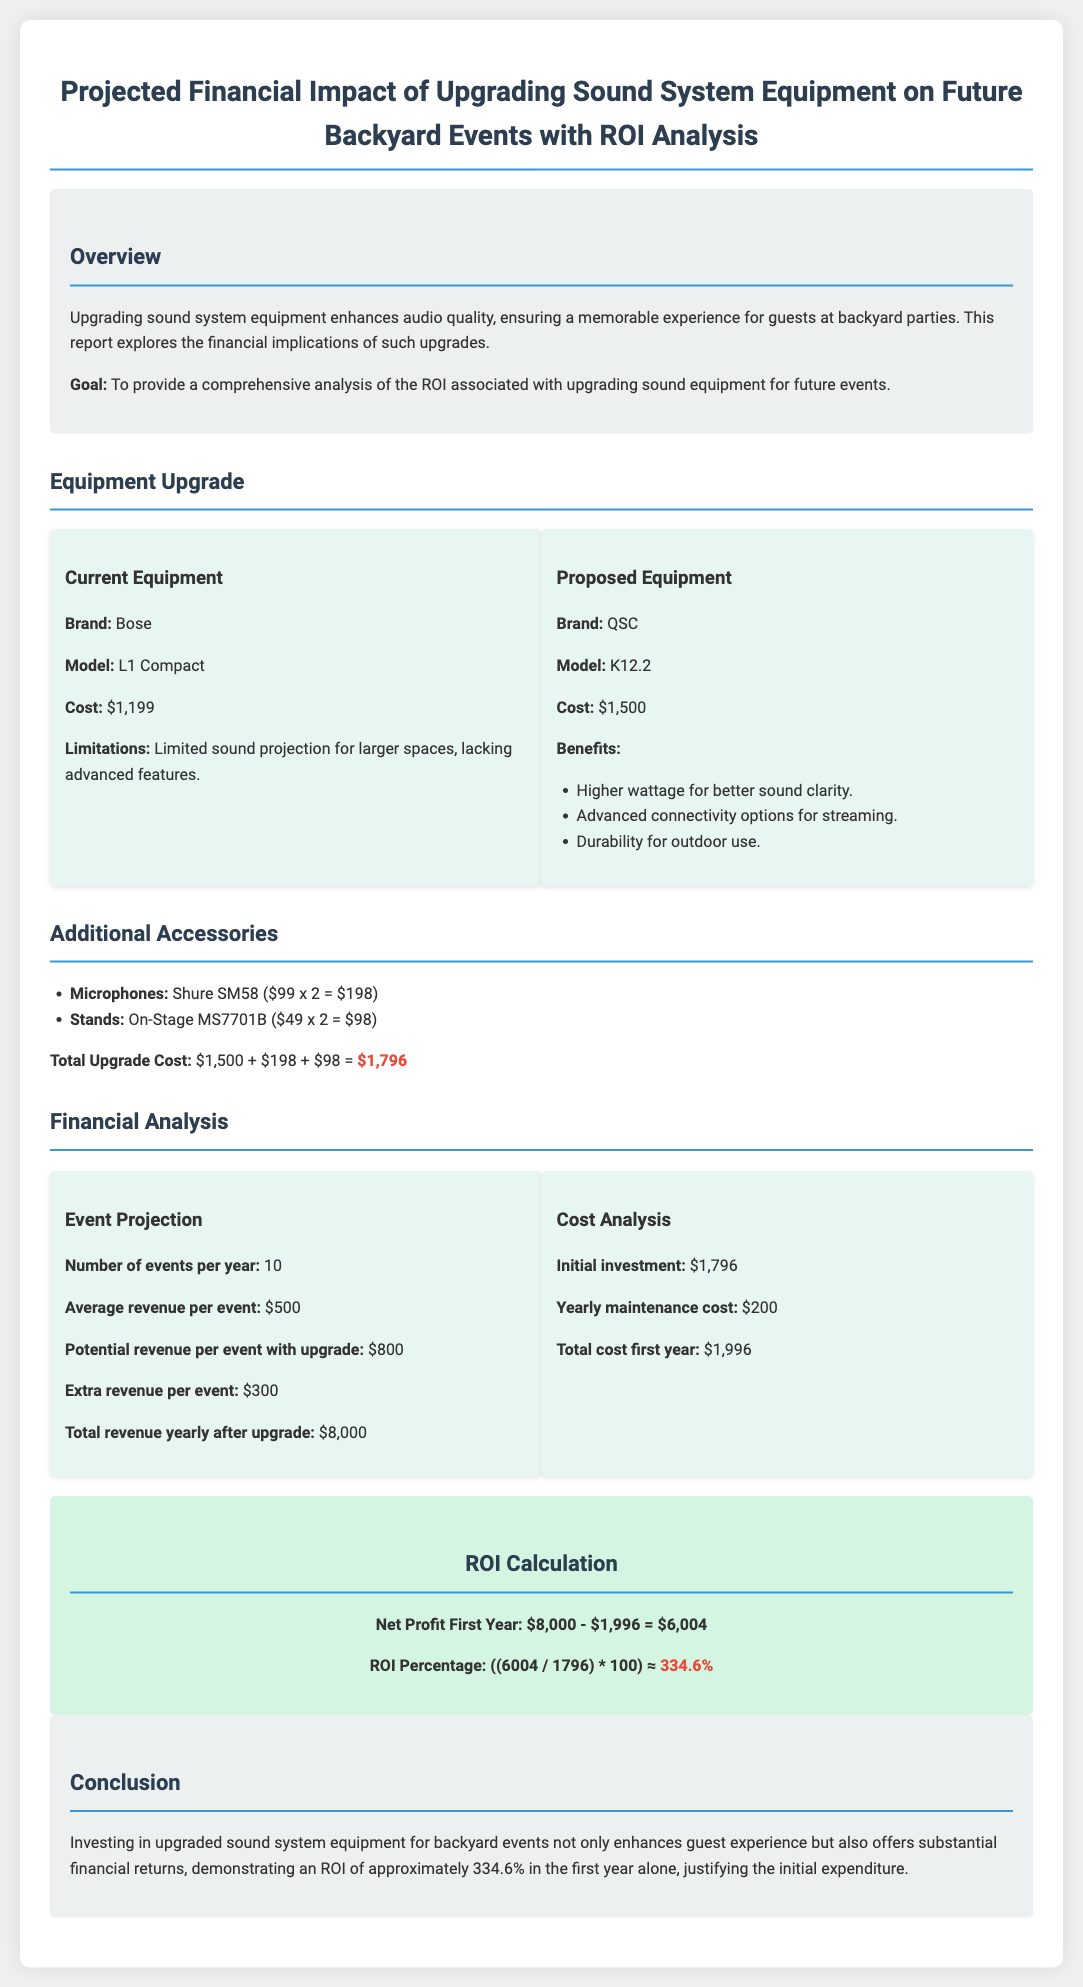What is the current sound system brand? The document states that the current sound system brand is Bose.
Answer: Bose What is the cost of the proposed equipment? The proposed equipment, QSC K12.2, costs $1,500 according to the document.
Answer: $1,500 What is the total upgrade cost for the sound system? The total upgrade cost is calculated as $1,500 + $198 + $98, which equals $1,796.
Answer: $1,796 How many events are projected per year? The document indicates that the number of events projected per year is 10.
Answer: 10 What is the ROI percentage calculated in the report? The report states that the ROI percentage is approximately 334.6%.
Answer: 334.6% What is the initial investment mentioned in the cost analysis? The initial investment highlighted in the cost analysis is $1,796.
Answer: $1,796 What is the extra revenue per event after the upgrade? The document states that the extra revenue per event with the upgrade is $300.
Answer: $300 What is the total revenue yearly after the upgrade? The total revenue yearly after the upgrade is mentioned as $8,000.
Answer: $8,000 What is the average revenue per event before the upgrade? The average revenue per event before the upgrade is $500 as stated in the document.
Answer: $500 What does the conclusion highlight about the investment? The conclusion emphasizes that the investment justifies the initial expenditure due to substantial financial returns.
Answer: Substantial financial returns 